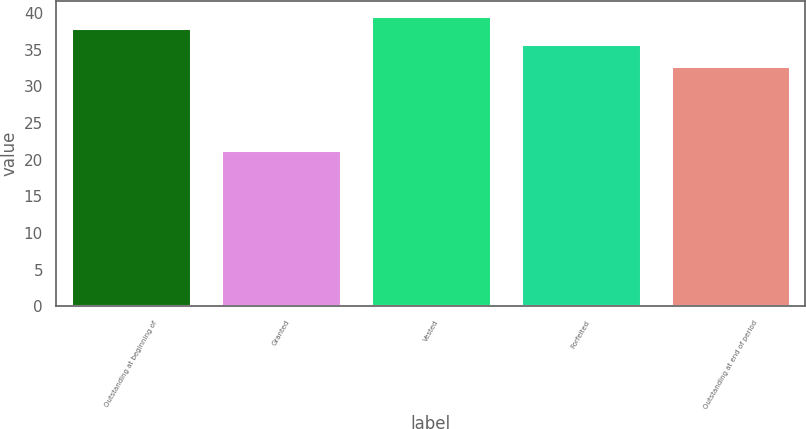<chart> <loc_0><loc_0><loc_500><loc_500><bar_chart><fcel>Outstanding at beginning of<fcel>Granted<fcel>Vested<fcel>Forfeited<fcel>Outstanding at end of period<nl><fcel>37.91<fcel>21.36<fcel>39.63<fcel>35.74<fcel>32.72<nl></chart> 